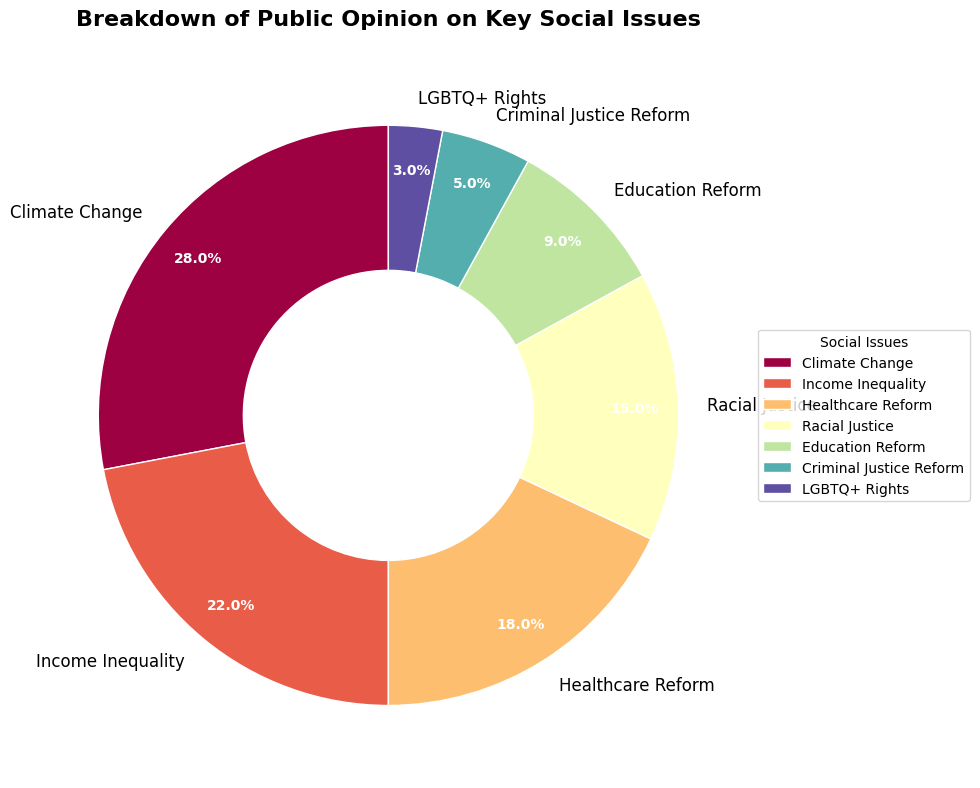What's the issue with the highest percentage of public opinion? The issue with the highest percentage of public opinion can be identified by looking for the largest segment in the pie chart. The largest segment represents Climate Change.
Answer: Climate Change What's the total percentage of public opinion represented by Climate Change and Healthcare Reform combined? To find the total percentage, add the percentages of Climate Change (28%) and Healthcare Reform (18%). Thus, 28% + 18% = 46%.
Answer: 46% Which has a higher percentage of public opinion, Education Reform or Criminal Justice Reform? Compare the percentages of Education Reform (9%) and Criminal Justice Reform (5%). Education Reform has a higher percentage.
Answer: Education Reform What is the difference in public opinion percentage between Income Inequality and Racial Justice? Subtract the percentage of Racial Justice (15%) from Income Inequality (22%). Thus, 22% - 15% = 7%.
Answer: 7% How many issues have a public opinion percentage of 10% or higher? Count the segments with percentages 10% or higher: Climate Change (28%), Income Inequality (22%), Healthcare Reform (18%), and Racial Justice (15%). There are 4 issues.
Answer: 4 What is the combined percentage for the issues with less than 10% public opinion? Add the percentages of issues below 10%: Education Reform (9%), Criminal Justice Reform (5%), and LGBTQ+ Rights (3%). Thus, 9% + 5% + 3% = 17%.
Answer: 17% Which issue has the smallest segment in the pie chart? Identify the smallest segment, which represents an issue with the lowest percentage. LGBTQ+ Rights has the smallest segment with 3%.
Answer: LGBTQ+ Rights Compare the visual widths of the segments representing Education Reform and Income Inequality. Which is larger? Visually compare the two segments. The segment for Income Inequality is larger than that for Education Reform, as its percentage is higher (22% vs 9%).
Answer: Income Inequality Is the sum of the percentages of Racial Justice and Education Reform greater than that of Climate Change? Add the percentages of Racial Justice (15%) and Education Reform (9%), then compare with Climate Change (28%). 15% + 9% = 24%, which is less than 28%.
Answer: No Which segment appears directly opposite to the starting segment of Climate Change at the 90 degrees start angle? Visually, the pie chart starts at 90 degrees and proceeds clockwise. The segment opposite will be around the 270 degrees position, which is approximately Racial Justice or Healthcare Reform.
Answer: Racial Justice or Healthcare Reform 